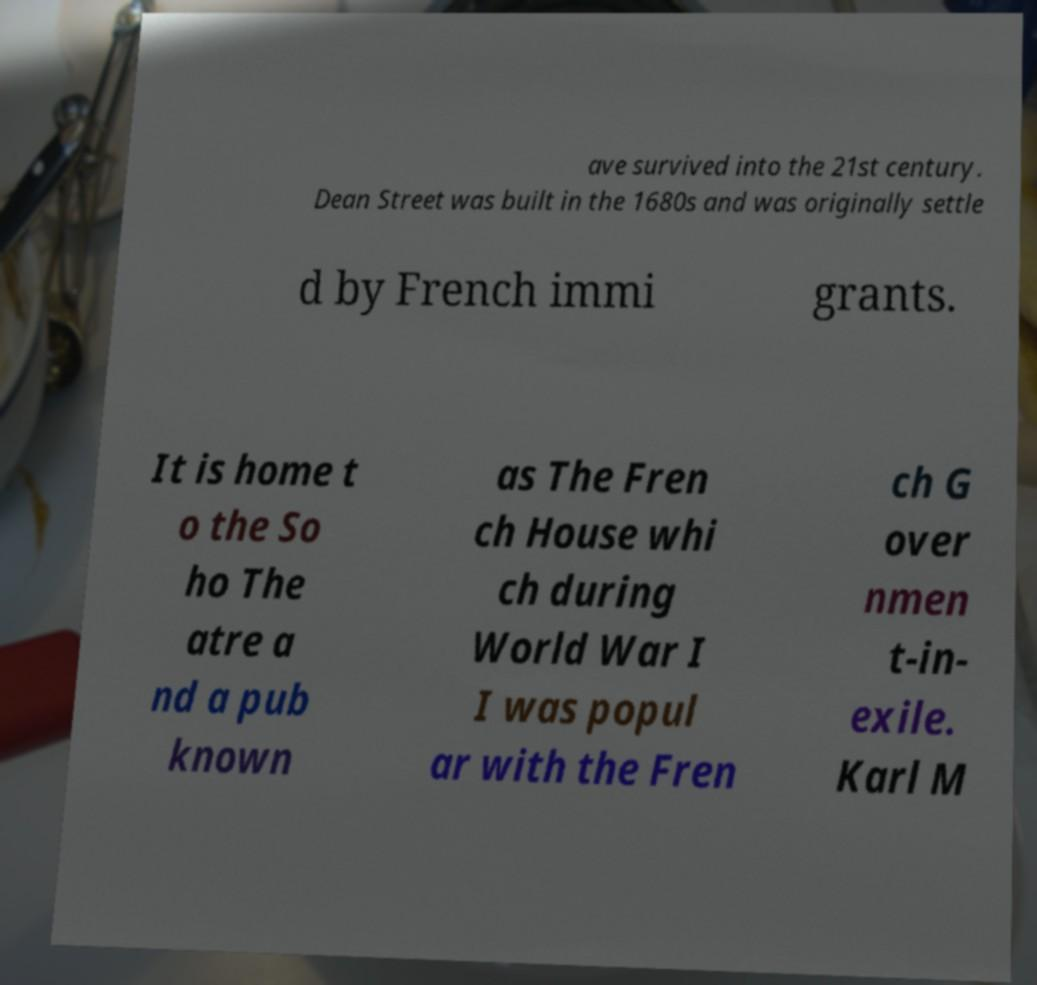Could you assist in decoding the text presented in this image and type it out clearly? ave survived into the 21st century. Dean Street was built in the 1680s and was originally settle d by French immi grants. It is home t o the So ho The atre a nd a pub known as The Fren ch House whi ch during World War I I was popul ar with the Fren ch G over nmen t-in- exile. Karl M 